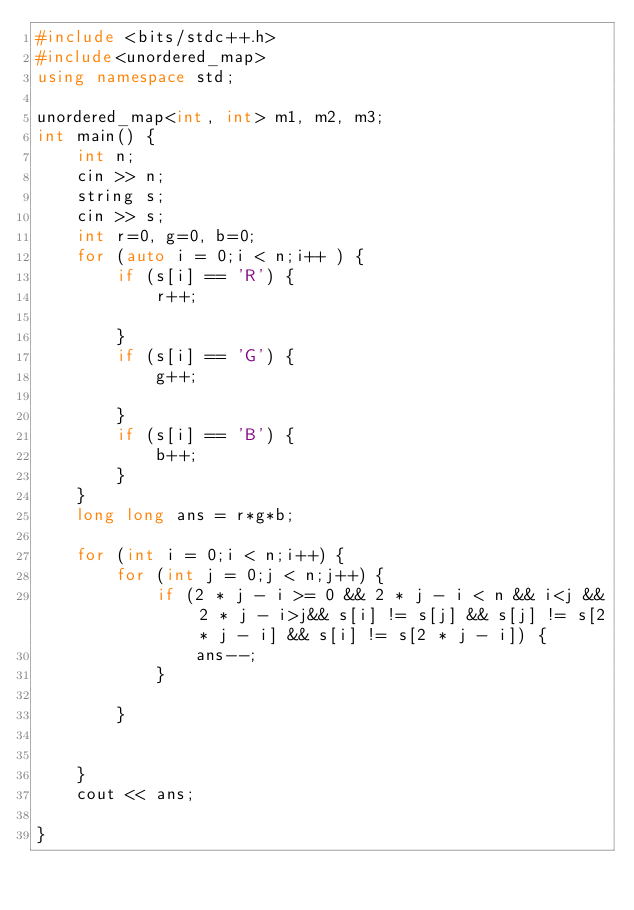<code> <loc_0><loc_0><loc_500><loc_500><_C++_>#include <bits/stdc++.h>
#include<unordered_map>
using namespace std;

unordered_map<int, int> m1, m2, m3;
int main() {
	int n;
	cin >> n;
	string s;
	cin >> s;
	int r=0, g=0, b=0;
	for (auto i = 0;i < n;i++ ) {
		if (s[i] == 'R') {
			r++;
			
		}
		if (s[i] == 'G') {
			g++;

		}
		if (s[i] == 'B') {
			b++;
		}
	}
	long long ans = r*g*b;

	for (int i = 0;i < n;i++) {
		for (int j = 0;j < n;j++) {
			if (2 * j - i >= 0 && 2 * j - i < n && i<j && 2 * j - i>j&& s[i] != s[j] && s[j] != s[2 * j - i] && s[i] != s[2 * j - i]) {
				ans--;
			}

		}


	}
	cout << ans;

}</code> 